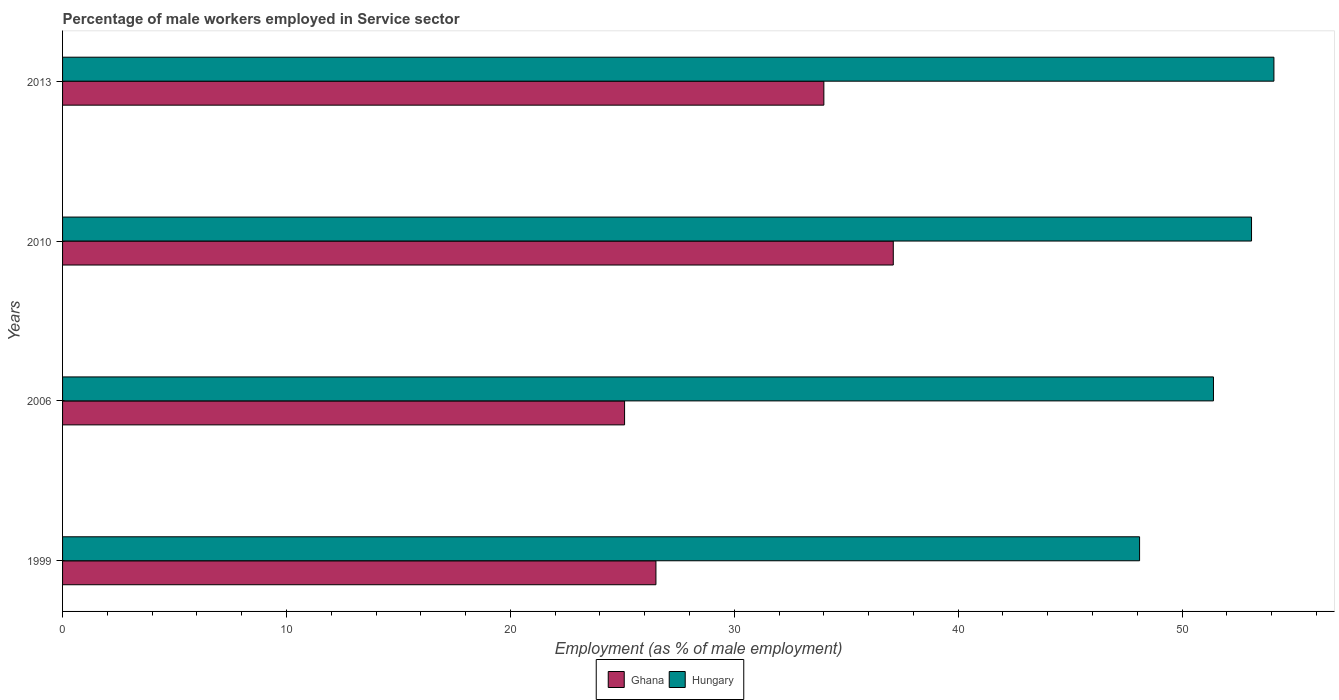Are the number of bars per tick equal to the number of legend labels?
Ensure brevity in your answer.  Yes. In how many cases, is the number of bars for a given year not equal to the number of legend labels?
Ensure brevity in your answer.  0. What is the percentage of male workers employed in Service sector in Ghana in 2006?
Keep it short and to the point. 25.1. Across all years, what is the maximum percentage of male workers employed in Service sector in Hungary?
Keep it short and to the point. 54.1. Across all years, what is the minimum percentage of male workers employed in Service sector in Hungary?
Keep it short and to the point. 48.1. In which year was the percentage of male workers employed in Service sector in Hungary maximum?
Your answer should be very brief. 2013. What is the total percentage of male workers employed in Service sector in Hungary in the graph?
Offer a very short reply. 206.7. What is the difference between the percentage of male workers employed in Service sector in Hungary in 1999 and that in 2006?
Provide a succinct answer. -3.3. What is the difference between the percentage of male workers employed in Service sector in Hungary in 2006 and the percentage of male workers employed in Service sector in Ghana in 1999?
Your answer should be compact. 24.9. What is the average percentage of male workers employed in Service sector in Ghana per year?
Your response must be concise. 30.67. In the year 2010, what is the difference between the percentage of male workers employed in Service sector in Ghana and percentage of male workers employed in Service sector in Hungary?
Give a very brief answer. -16. In how many years, is the percentage of male workers employed in Service sector in Ghana greater than 32 %?
Offer a very short reply. 2. What is the ratio of the percentage of male workers employed in Service sector in Ghana in 2010 to that in 2013?
Offer a very short reply. 1.09. What is the difference between the highest and the second highest percentage of male workers employed in Service sector in Ghana?
Provide a succinct answer. 3.1. In how many years, is the percentage of male workers employed in Service sector in Hungary greater than the average percentage of male workers employed in Service sector in Hungary taken over all years?
Offer a terse response. 2. Is the sum of the percentage of male workers employed in Service sector in Ghana in 2006 and 2010 greater than the maximum percentage of male workers employed in Service sector in Hungary across all years?
Give a very brief answer. Yes. What does the 1st bar from the top in 2013 represents?
Provide a short and direct response. Hungary. How many bars are there?
Ensure brevity in your answer.  8. Are all the bars in the graph horizontal?
Your response must be concise. Yes. What is the difference between two consecutive major ticks on the X-axis?
Offer a terse response. 10. Are the values on the major ticks of X-axis written in scientific E-notation?
Your response must be concise. No. How many legend labels are there?
Offer a terse response. 2. What is the title of the graph?
Ensure brevity in your answer.  Percentage of male workers employed in Service sector. Does "Other small states" appear as one of the legend labels in the graph?
Offer a very short reply. No. What is the label or title of the X-axis?
Ensure brevity in your answer.  Employment (as % of male employment). What is the label or title of the Y-axis?
Keep it short and to the point. Years. What is the Employment (as % of male employment) in Hungary in 1999?
Offer a terse response. 48.1. What is the Employment (as % of male employment) of Ghana in 2006?
Give a very brief answer. 25.1. What is the Employment (as % of male employment) in Hungary in 2006?
Ensure brevity in your answer.  51.4. What is the Employment (as % of male employment) in Ghana in 2010?
Give a very brief answer. 37.1. What is the Employment (as % of male employment) of Hungary in 2010?
Offer a very short reply. 53.1. What is the Employment (as % of male employment) in Hungary in 2013?
Your answer should be compact. 54.1. Across all years, what is the maximum Employment (as % of male employment) of Ghana?
Make the answer very short. 37.1. Across all years, what is the maximum Employment (as % of male employment) of Hungary?
Provide a succinct answer. 54.1. Across all years, what is the minimum Employment (as % of male employment) in Ghana?
Provide a short and direct response. 25.1. Across all years, what is the minimum Employment (as % of male employment) of Hungary?
Your response must be concise. 48.1. What is the total Employment (as % of male employment) in Ghana in the graph?
Offer a terse response. 122.7. What is the total Employment (as % of male employment) in Hungary in the graph?
Make the answer very short. 206.7. What is the difference between the Employment (as % of male employment) in Ghana in 1999 and that in 2010?
Give a very brief answer. -10.6. What is the difference between the Employment (as % of male employment) in Hungary in 1999 and that in 2010?
Keep it short and to the point. -5. What is the difference between the Employment (as % of male employment) of Ghana in 1999 and that in 2013?
Your response must be concise. -7.5. What is the difference between the Employment (as % of male employment) of Ghana in 2006 and that in 2010?
Offer a very short reply. -12. What is the difference between the Employment (as % of male employment) of Ghana in 2006 and that in 2013?
Give a very brief answer. -8.9. What is the difference between the Employment (as % of male employment) in Hungary in 2006 and that in 2013?
Provide a short and direct response. -2.7. What is the difference between the Employment (as % of male employment) of Ghana in 2010 and that in 2013?
Make the answer very short. 3.1. What is the difference between the Employment (as % of male employment) in Ghana in 1999 and the Employment (as % of male employment) in Hungary in 2006?
Provide a succinct answer. -24.9. What is the difference between the Employment (as % of male employment) of Ghana in 1999 and the Employment (as % of male employment) of Hungary in 2010?
Keep it short and to the point. -26.6. What is the difference between the Employment (as % of male employment) of Ghana in 1999 and the Employment (as % of male employment) of Hungary in 2013?
Your answer should be compact. -27.6. What is the difference between the Employment (as % of male employment) of Ghana in 2006 and the Employment (as % of male employment) of Hungary in 2010?
Provide a succinct answer. -28. What is the difference between the Employment (as % of male employment) in Ghana in 2010 and the Employment (as % of male employment) in Hungary in 2013?
Make the answer very short. -17. What is the average Employment (as % of male employment) of Ghana per year?
Make the answer very short. 30.68. What is the average Employment (as % of male employment) in Hungary per year?
Provide a succinct answer. 51.67. In the year 1999, what is the difference between the Employment (as % of male employment) of Ghana and Employment (as % of male employment) of Hungary?
Give a very brief answer. -21.6. In the year 2006, what is the difference between the Employment (as % of male employment) in Ghana and Employment (as % of male employment) in Hungary?
Your response must be concise. -26.3. In the year 2010, what is the difference between the Employment (as % of male employment) in Ghana and Employment (as % of male employment) in Hungary?
Provide a succinct answer. -16. In the year 2013, what is the difference between the Employment (as % of male employment) in Ghana and Employment (as % of male employment) in Hungary?
Offer a terse response. -20.1. What is the ratio of the Employment (as % of male employment) of Ghana in 1999 to that in 2006?
Give a very brief answer. 1.06. What is the ratio of the Employment (as % of male employment) of Hungary in 1999 to that in 2006?
Your answer should be compact. 0.94. What is the ratio of the Employment (as % of male employment) of Hungary in 1999 to that in 2010?
Your response must be concise. 0.91. What is the ratio of the Employment (as % of male employment) in Ghana in 1999 to that in 2013?
Your answer should be very brief. 0.78. What is the ratio of the Employment (as % of male employment) of Hungary in 1999 to that in 2013?
Offer a terse response. 0.89. What is the ratio of the Employment (as % of male employment) in Ghana in 2006 to that in 2010?
Give a very brief answer. 0.68. What is the ratio of the Employment (as % of male employment) in Ghana in 2006 to that in 2013?
Provide a succinct answer. 0.74. What is the ratio of the Employment (as % of male employment) of Hungary in 2006 to that in 2013?
Provide a succinct answer. 0.95. What is the ratio of the Employment (as % of male employment) in Ghana in 2010 to that in 2013?
Ensure brevity in your answer.  1.09. What is the ratio of the Employment (as % of male employment) in Hungary in 2010 to that in 2013?
Offer a terse response. 0.98. What is the difference between the highest and the second highest Employment (as % of male employment) in Ghana?
Your answer should be compact. 3.1. What is the difference between the highest and the lowest Employment (as % of male employment) of Hungary?
Offer a very short reply. 6. 